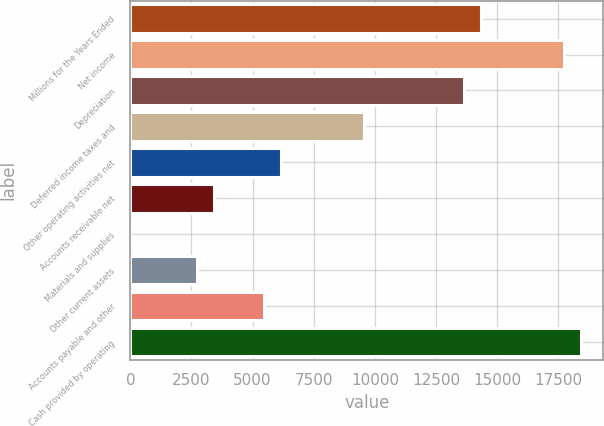Convert chart to OTSL. <chart><loc_0><loc_0><loc_500><loc_500><bar_chart><fcel>Millions for the Years Ended<fcel>Net income<fcel>Depreciation<fcel>Deferred income taxes and<fcel>Other operating activities net<fcel>Accounts receivable net<fcel>Materials and supplies<fcel>Other current assets<fcel>Accounts payable and other<fcel>Cash provided by operating<nl><fcel>14320.6<fcel>17728.6<fcel>13639<fcel>9549.4<fcel>6141.4<fcel>3415<fcel>7<fcel>2733.4<fcel>5459.8<fcel>18410.2<nl></chart> 